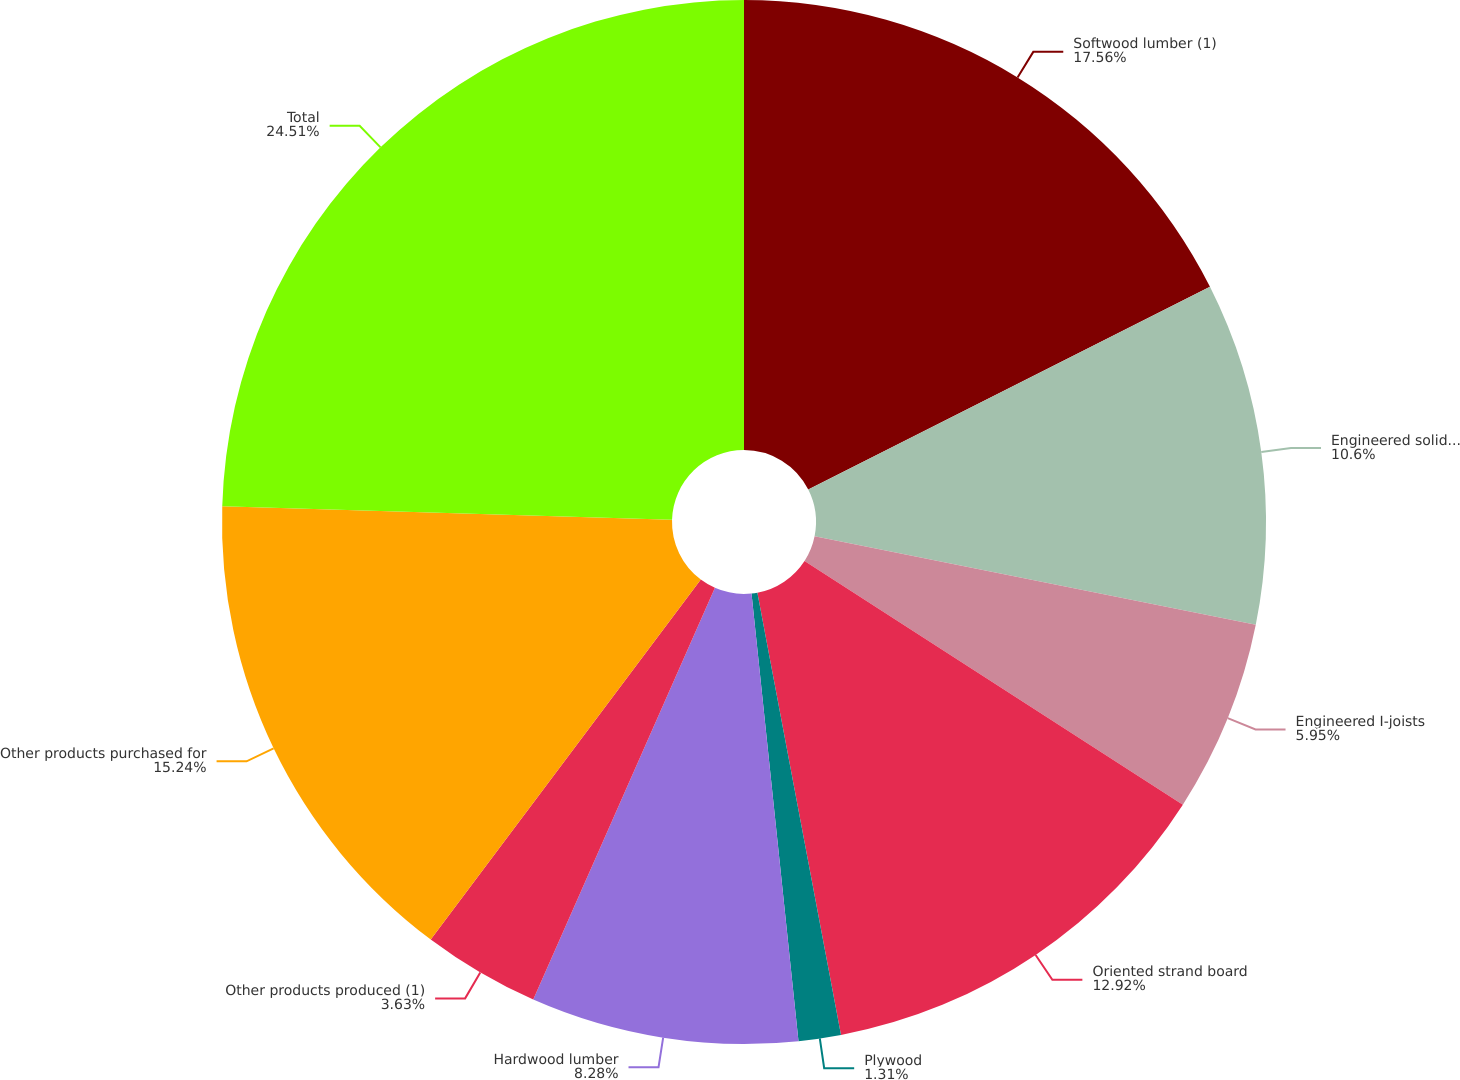<chart> <loc_0><loc_0><loc_500><loc_500><pie_chart><fcel>Softwood lumber (1)<fcel>Engineered solid section<fcel>Engineered I-joists<fcel>Oriented strand board<fcel>Plywood<fcel>Hardwood lumber<fcel>Other products produced (1)<fcel>Other products purchased for<fcel>Total<nl><fcel>17.56%<fcel>10.6%<fcel>5.95%<fcel>12.92%<fcel>1.31%<fcel>8.28%<fcel>3.63%<fcel>15.24%<fcel>24.52%<nl></chart> 